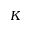<formula> <loc_0><loc_0><loc_500><loc_500>K</formula> 